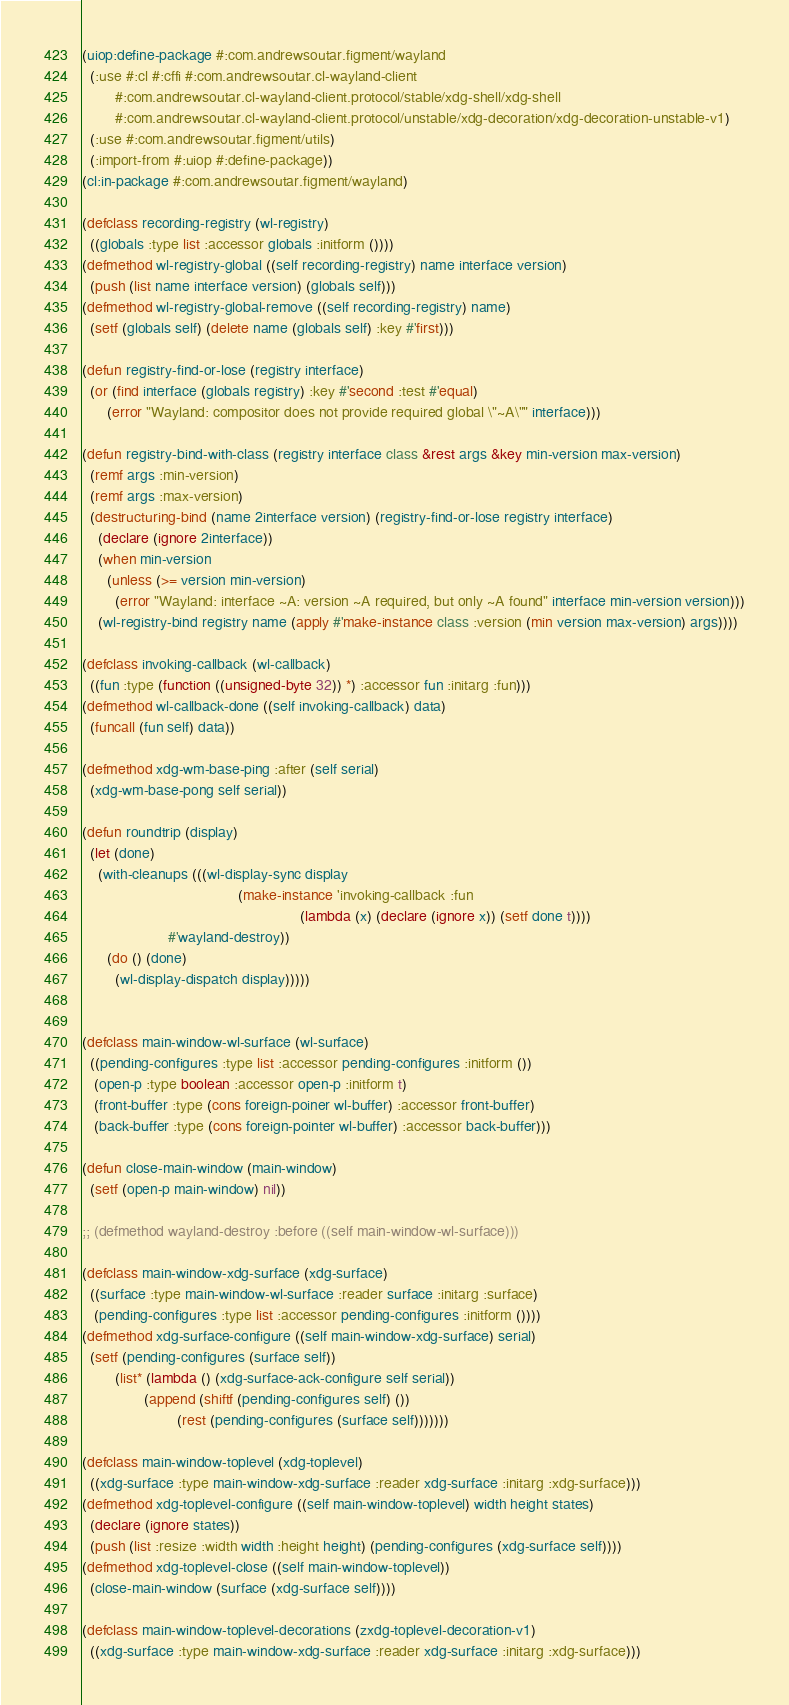<code> <loc_0><loc_0><loc_500><loc_500><_Lisp_>(uiop:define-package #:com.andrewsoutar.figment/wayland
  (:use #:cl #:cffi #:com.andrewsoutar.cl-wayland-client
        #:com.andrewsoutar.cl-wayland-client.protocol/stable/xdg-shell/xdg-shell
        #:com.andrewsoutar.cl-wayland-client.protocol/unstable/xdg-decoration/xdg-decoration-unstable-v1)
  (:use #:com.andrewsoutar.figment/utils)
  (:import-from #:uiop #:define-package))
(cl:in-package #:com.andrewsoutar.figment/wayland)

(defclass recording-registry (wl-registry)
  ((globals :type list :accessor globals :initform ())))
(defmethod wl-registry-global ((self recording-registry) name interface version)
  (push (list name interface version) (globals self)))
(defmethod wl-registry-global-remove ((self recording-registry) name)
  (setf (globals self) (delete name (globals self) :key #'first)))

(defun registry-find-or-lose (registry interface)
  (or (find interface (globals registry) :key #'second :test #'equal)
      (error "Wayland: compositor does not provide required global \"~A\"" interface)))

(defun registry-bind-with-class (registry interface class &rest args &key min-version max-version)
  (remf args :min-version)
  (remf args :max-version)
  (destructuring-bind (name 2interface version) (registry-find-or-lose registry interface)
    (declare (ignore 2interface))
    (when min-version
      (unless (>= version min-version)
        (error "Wayland: interface ~A: version ~A required, but only ~A found" interface min-version version)))
    (wl-registry-bind registry name (apply #'make-instance class :version (min version max-version) args))))

(defclass invoking-callback (wl-callback)
  ((fun :type (function ((unsigned-byte 32)) *) :accessor fun :initarg :fun)))
(defmethod wl-callback-done ((self invoking-callback) data)
  (funcall (fun self) data))

(defmethod xdg-wm-base-ping :after (self serial)
  (xdg-wm-base-pong self serial))

(defun roundtrip (display)
  (let (done)
    (with-cleanups (((wl-display-sync display
                                      (make-instance 'invoking-callback :fun
                                                     (lambda (x) (declare (ignore x)) (setf done t))))
                     #'wayland-destroy))
      (do () (done)
        (wl-display-dispatch display)))))


(defclass main-window-wl-surface (wl-surface)
  ((pending-configures :type list :accessor pending-configures :initform ())
   (open-p :type boolean :accessor open-p :initform t)
   (front-buffer :type (cons foreign-poiner wl-buffer) :accessor front-buffer)
   (back-buffer :type (cons foreign-pointer wl-buffer) :accessor back-buffer)))

(defun close-main-window (main-window)
  (setf (open-p main-window) nil))

;; (defmethod wayland-destroy :before ((self main-window-wl-surface)))

(defclass main-window-xdg-surface (xdg-surface)
  ((surface :type main-window-wl-surface :reader surface :initarg :surface)
   (pending-configures :type list :accessor pending-configures :initform ())))
(defmethod xdg-surface-configure ((self main-window-xdg-surface) serial)
  (setf (pending-configures (surface self))
        (list* (lambda () (xdg-surface-ack-configure self serial))
               (append (shiftf (pending-configures self) ())
                       (rest (pending-configures (surface self)))))))

(defclass main-window-toplevel (xdg-toplevel)
  ((xdg-surface :type main-window-xdg-surface :reader xdg-surface :initarg :xdg-surface)))
(defmethod xdg-toplevel-configure ((self main-window-toplevel) width height states)
  (declare (ignore states))
  (push (list :resize :width width :height height) (pending-configures (xdg-surface self))))
(defmethod xdg-toplevel-close ((self main-window-toplevel))
  (close-main-window (surface (xdg-surface self))))

(defclass main-window-toplevel-decorations (zxdg-toplevel-decoration-v1)
  ((xdg-surface :type main-window-xdg-surface :reader xdg-surface :initarg :xdg-surface)))</code> 